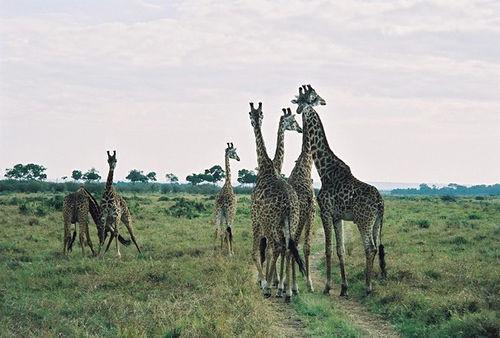How many giraffe are walking in the grass?
Give a very brief answer. 7. How many animals?
Give a very brief answer. 7. How many giraffes are there?
Give a very brief answer. 2. 